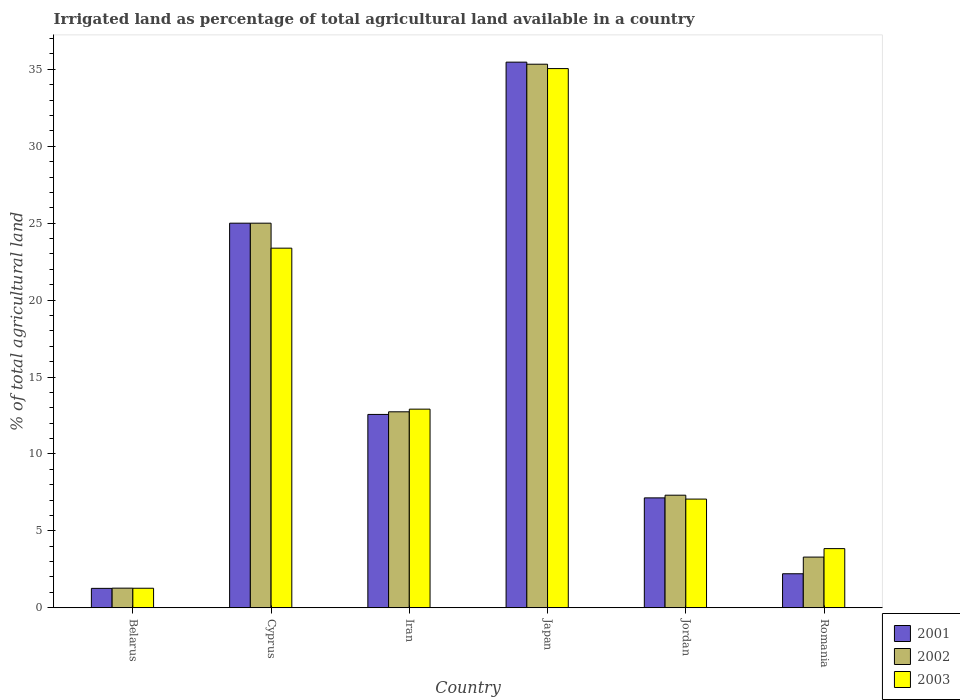Are the number of bars on each tick of the X-axis equal?
Your answer should be compact. Yes. What is the label of the 1st group of bars from the left?
Your response must be concise. Belarus. What is the percentage of irrigated land in 2001 in Iran?
Your response must be concise. 12.57. Across all countries, what is the maximum percentage of irrigated land in 2001?
Offer a very short reply. 35.47. Across all countries, what is the minimum percentage of irrigated land in 2003?
Ensure brevity in your answer.  1.27. In which country was the percentage of irrigated land in 2001 maximum?
Offer a terse response. Japan. In which country was the percentage of irrigated land in 2002 minimum?
Your answer should be compact. Belarus. What is the total percentage of irrigated land in 2002 in the graph?
Offer a very short reply. 84.96. What is the difference between the percentage of irrigated land in 2002 in Belarus and that in Romania?
Your response must be concise. -2.02. What is the difference between the percentage of irrigated land in 2002 in Cyprus and the percentage of irrigated land in 2001 in Iran?
Make the answer very short. 12.43. What is the average percentage of irrigated land in 2001 per country?
Provide a short and direct response. 13.94. What is the difference between the percentage of irrigated land of/in 2001 and percentage of irrigated land of/in 2003 in Belarus?
Offer a very short reply. -0.01. In how many countries, is the percentage of irrigated land in 2001 greater than 8 %?
Give a very brief answer. 3. What is the ratio of the percentage of irrigated land in 2003 in Cyprus to that in Iran?
Keep it short and to the point. 1.81. Is the percentage of irrigated land in 2003 in Iran less than that in Japan?
Keep it short and to the point. Yes. What is the difference between the highest and the second highest percentage of irrigated land in 2001?
Ensure brevity in your answer.  -10.47. What is the difference between the highest and the lowest percentage of irrigated land in 2002?
Offer a terse response. 34.06. What does the 2nd bar from the right in Jordan represents?
Your response must be concise. 2002. Is it the case that in every country, the sum of the percentage of irrigated land in 2001 and percentage of irrigated land in 2003 is greater than the percentage of irrigated land in 2002?
Give a very brief answer. Yes. How many bars are there?
Keep it short and to the point. 18. Are all the bars in the graph horizontal?
Offer a very short reply. No. How many countries are there in the graph?
Your answer should be compact. 6. What is the difference between two consecutive major ticks on the Y-axis?
Keep it short and to the point. 5. Does the graph contain any zero values?
Provide a short and direct response. No. Does the graph contain grids?
Give a very brief answer. No. What is the title of the graph?
Offer a very short reply. Irrigated land as percentage of total agricultural land available in a country. What is the label or title of the Y-axis?
Your answer should be very brief. % of total agricultural land. What is the % of total agricultural land in 2001 in Belarus?
Give a very brief answer. 1.26. What is the % of total agricultural land of 2002 in Belarus?
Give a very brief answer. 1.27. What is the % of total agricultural land in 2003 in Belarus?
Give a very brief answer. 1.27. What is the % of total agricultural land in 2001 in Cyprus?
Provide a succinct answer. 25. What is the % of total agricultural land of 2003 in Cyprus?
Provide a short and direct response. 23.38. What is the % of total agricultural land of 2001 in Iran?
Make the answer very short. 12.57. What is the % of total agricultural land in 2002 in Iran?
Your answer should be very brief. 12.74. What is the % of total agricultural land in 2003 in Iran?
Your response must be concise. 12.91. What is the % of total agricultural land of 2001 in Japan?
Your response must be concise. 35.47. What is the % of total agricultural land of 2002 in Japan?
Keep it short and to the point. 35.33. What is the % of total agricultural land of 2003 in Japan?
Your answer should be very brief. 35.05. What is the % of total agricultural land in 2001 in Jordan?
Make the answer very short. 7.14. What is the % of total agricultural land in 2002 in Jordan?
Give a very brief answer. 7.32. What is the % of total agricultural land in 2003 in Jordan?
Keep it short and to the point. 7.06. What is the % of total agricultural land in 2001 in Romania?
Provide a short and direct response. 2.21. What is the % of total agricultural land of 2002 in Romania?
Offer a terse response. 3.29. What is the % of total agricultural land of 2003 in Romania?
Keep it short and to the point. 3.84. Across all countries, what is the maximum % of total agricultural land in 2001?
Give a very brief answer. 35.47. Across all countries, what is the maximum % of total agricultural land in 2002?
Make the answer very short. 35.33. Across all countries, what is the maximum % of total agricultural land in 2003?
Keep it short and to the point. 35.05. Across all countries, what is the minimum % of total agricultural land of 2001?
Make the answer very short. 1.26. Across all countries, what is the minimum % of total agricultural land in 2002?
Keep it short and to the point. 1.27. Across all countries, what is the minimum % of total agricultural land in 2003?
Offer a terse response. 1.27. What is the total % of total agricultural land of 2001 in the graph?
Provide a succinct answer. 83.65. What is the total % of total agricultural land in 2002 in the graph?
Offer a terse response. 84.96. What is the total % of total agricultural land in 2003 in the graph?
Give a very brief answer. 83.52. What is the difference between the % of total agricultural land of 2001 in Belarus and that in Cyprus?
Offer a very short reply. -23.74. What is the difference between the % of total agricultural land in 2002 in Belarus and that in Cyprus?
Offer a very short reply. -23.73. What is the difference between the % of total agricultural land of 2003 in Belarus and that in Cyprus?
Ensure brevity in your answer.  -22.11. What is the difference between the % of total agricultural land of 2001 in Belarus and that in Iran?
Make the answer very short. -11.31. What is the difference between the % of total agricultural land in 2002 in Belarus and that in Iran?
Make the answer very short. -11.46. What is the difference between the % of total agricultural land in 2003 in Belarus and that in Iran?
Make the answer very short. -11.64. What is the difference between the % of total agricultural land of 2001 in Belarus and that in Japan?
Provide a short and direct response. -34.21. What is the difference between the % of total agricultural land in 2002 in Belarus and that in Japan?
Keep it short and to the point. -34.06. What is the difference between the % of total agricultural land in 2003 in Belarus and that in Japan?
Your response must be concise. -33.78. What is the difference between the % of total agricultural land of 2001 in Belarus and that in Jordan?
Ensure brevity in your answer.  -5.88. What is the difference between the % of total agricultural land in 2002 in Belarus and that in Jordan?
Provide a succinct answer. -6.04. What is the difference between the % of total agricultural land in 2003 in Belarus and that in Jordan?
Give a very brief answer. -5.8. What is the difference between the % of total agricultural land in 2001 in Belarus and that in Romania?
Your answer should be compact. -0.95. What is the difference between the % of total agricultural land of 2002 in Belarus and that in Romania?
Your answer should be compact. -2.02. What is the difference between the % of total agricultural land in 2003 in Belarus and that in Romania?
Your answer should be compact. -2.58. What is the difference between the % of total agricultural land of 2001 in Cyprus and that in Iran?
Your response must be concise. 12.43. What is the difference between the % of total agricultural land in 2002 in Cyprus and that in Iran?
Give a very brief answer. 12.26. What is the difference between the % of total agricultural land in 2003 in Cyprus and that in Iran?
Provide a succinct answer. 10.47. What is the difference between the % of total agricultural land in 2001 in Cyprus and that in Japan?
Provide a succinct answer. -10.47. What is the difference between the % of total agricultural land of 2002 in Cyprus and that in Japan?
Ensure brevity in your answer.  -10.33. What is the difference between the % of total agricultural land in 2003 in Cyprus and that in Japan?
Ensure brevity in your answer.  -11.67. What is the difference between the % of total agricultural land in 2001 in Cyprus and that in Jordan?
Your answer should be very brief. 17.86. What is the difference between the % of total agricultural land of 2002 in Cyprus and that in Jordan?
Your response must be concise. 17.68. What is the difference between the % of total agricultural land in 2003 in Cyprus and that in Jordan?
Offer a very short reply. 16.31. What is the difference between the % of total agricultural land of 2001 in Cyprus and that in Romania?
Offer a terse response. 22.79. What is the difference between the % of total agricultural land of 2002 in Cyprus and that in Romania?
Ensure brevity in your answer.  21.71. What is the difference between the % of total agricultural land in 2003 in Cyprus and that in Romania?
Offer a terse response. 19.53. What is the difference between the % of total agricultural land of 2001 in Iran and that in Japan?
Provide a succinct answer. -22.9. What is the difference between the % of total agricultural land of 2002 in Iran and that in Japan?
Give a very brief answer. -22.6. What is the difference between the % of total agricultural land of 2003 in Iran and that in Japan?
Make the answer very short. -22.14. What is the difference between the % of total agricultural land of 2001 in Iran and that in Jordan?
Provide a short and direct response. 5.42. What is the difference between the % of total agricultural land of 2002 in Iran and that in Jordan?
Keep it short and to the point. 5.42. What is the difference between the % of total agricultural land of 2003 in Iran and that in Jordan?
Your answer should be compact. 5.85. What is the difference between the % of total agricultural land of 2001 in Iran and that in Romania?
Offer a very short reply. 10.36. What is the difference between the % of total agricultural land in 2002 in Iran and that in Romania?
Make the answer very short. 9.44. What is the difference between the % of total agricultural land in 2003 in Iran and that in Romania?
Provide a short and direct response. 9.07. What is the difference between the % of total agricultural land of 2001 in Japan and that in Jordan?
Offer a very short reply. 28.33. What is the difference between the % of total agricultural land in 2002 in Japan and that in Jordan?
Provide a succinct answer. 28.02. What is the difference between the % of total agricultural land in 2003 in Japan and that in Jordan?
Make the answer very short. 27.99. What is the difference between the % of total agricultural land in 2001 in Japan and that in Romania?
Provide a short and direct response. 33.26. What is the difference between the % of total agricultural land of 2002 in Japan and that in Romania?
Make the answer very short. 32.04. What is the difference between the % of total agricultural land in 2003 in Japan and that in Romania?
Offer a terse response. 31.21. What is the difference between the % of total agricultural land in 2001 in Jordan and that in Romania?
Your answer should be very brief. 4.93. What is the difference between the % of total agricultural land of 2002 in Jordan and that in Romania?
Ensure brevity in your answer.  4.02. What is the difference between the % of total agricultural land in 2003 in Jordan and that in Romania?
Keep it short and to the point. 3.22. What is the difference between the % of total agricultural land of 2001 in Belarus and the % of total agricultural land of 2002 in Cyprus?
Your response must be concise. -23.74. What is the difference between the % of total agricultural land of 2001 in Belarus and the % of total agricultural land of 2003 in Cyprus?
Ensure brevity in your answer.  -22.12. What is the difference between the % of total agricultural land of 2002 in Belarus and the % of total agricultural land of 2003 in Cyprus?
Keep it short and to the point. -22.1. What is the difference between the % of total agricultural land of 2001 in Belarus and the % of total agricultural land of 2002 in Iran?
Provide a succinct answer. -11.48. What is the difference between the % of total agricultural land of 2001 in Belarus and the % of total agricultural land of 2003 in Iran?
Offer a very short reply. -11.65. What is the difference between the % of total agricultural land in 2002 in Belarus and the % of total agricultural land in 2003 in Iran?
Offer a terse response. -11.64. What is the difference between the % of total agricultural land in 2001 in Belarus and the % of total agricultural land in 2002 in Japan?
Give a very brief answer. -34.08. What is the difference between the % of total agricultural land of 2001 in Belarus and the % of total agricultural land of 2003 in Japan?
Make the answer very short. -33.79. What is the difference between the % of total agricultural land in 2002 in Belarus and the % of total agricultural land in 2003 in Japan?
Provide a succinct answer. -33.78. What is the difference between the % of total agricultural land of 2001 in Belarus and the % of total agricultural land of 2002 in Jordan?
Offer a terse response. -6.06. What is the difference between the % of total agricultural land in 2001 in Belarus and the % of total agricultural land in 2003 in Jordan?
Keep it short and to the point. -5.8. What is the difference between the % of total agricultural land of 2002 in Belarus and the % of total agricultural land of 2003 in Jordan?
Give a very brief answer. -5.79. What is the difference between the % of total agricultural land in 2001 in Belarus and the % of total agricultural land in 2002 in Romania?
Make the answer very short. -2.03. What is the difference between the % of total agricultural land in 2001 in Belarus and the % of total agricultural land in 2003 in Romania?
Your answer should be compact. -2.58. What is the difference between the % of total agricultural land of 2002 in Belarus and the % of total agricultural land of 2003 in Romania?
Make the answer very short. -2.57. What is the difference between the % of total agricultural land in 2001 in Cyprus and the % of total agricultural land in 2002 in Iran?
Ensure brevity in your answer.  12.26. What is the difference between the % of total agricultural land in 2001 in Cyprus and the % of total agricultural land in 2003 in Iran?
Offer a very short reply. 12.09. What is the difference between the % of total agricultural land in 2002 in Cyprus and the % of total agricultural land in 2003 in Iran?
Make the answer very short. 12.09. What is the difference between the % of total agricultural land in 2001 in Cyprus and the % of total agricultural land in 2002 in Japan?
Ensure brevity in your answer.  -10.33. What is the difference between the % of total agricultural land of 2001 in Cyprus and the % of total agricultural land of 2003 in Japan?
Your answer should be compact. -10.05. What is the difference between the % of total agricultural land of 2002 in Cyprus and the % of total agricultural land of 2003 in Japan?
Keep it short and to the point. -10.05. What is the difference between the % of total agricultural land of 2001 in Cyprus and the % of total agricultural land of 2002 in Jordan?
Give a very brief answer. 17.68. What is the difference between the % of total agricultural land of 2001 in Cyprus and the % of total agricultural land of 2003 in Jordan?
Your answer should be very brief. 17.94. What is the difference between the % of total agricultural land of 2002 in Cyprus and the % of total agricultural land of 2003 in Jordan?
Offer a terse response. 17.94. What is the difference between the % of total agricultural land in 2001 in Cyprus and the % of total agricultural land in 2002 in Romania?
Ensure brevity in your answer.  21.71. What is the difference between the % of total agricultural land of 2001 in Cyprus and the % of total agricultural land of 2003 in Romania?
Keep it short and to the point. 21.16. What is the difference between the % of total agricultural land in 2002 in Cyprus and the % of total agricultural land in 2003 in Romania?
Your answer should be compact. 21.16. What is the difference between the % of total agricultural land in 2001 in Iran and the % of total agricultural land in 2002 in Japan?
Offer a terse response. -22.77. What is the difference between the % of total agricultural land of 2001 in Iran and the % of total agricultural land of 2003 in Japan?
Make the answer very short. -22.48. What is the difference between the % of total agricultural land in 2002 in Iran and the % of total agricultural land in 2003 in Japan?
Provide a short and direct response. -22.31. What is the difference between the % of total agricultural land in 2001 in Iran and the % of total agricultural land in 2002 in Jordan?
Offer a terse response. 5.25. What is the difference between the % of total agricultural land in 2001 in Iran and the % of total agricultural land in 2003 in Jordan?
Provide a short and direct response. 5.5. What is the difference between the % of total agricultural land of 2002 in Iran and the % of total agricultural land of 2003 in Jordan?
Your answer should be very brief. 5.67. What is the difference between the % of total agricultural land of 2001 in Iran and the % of total agricultural land of 2002 in Romania?
Your response must be concise. 9.27. What is the difference between the % of total agricultural land of 2001 in Iran and the % of total agricultural land of 2003 in Romania?
Your response must be concise. 8.72. What is the difference between the % of total agricultural land in 2002 in Iran and the % of total agricultural land in 2003 in Romania?
Offer a terse response. 8.89. What is the difference between the % of total agricultural land of 2001 in Japan and the % of total agricultural land of 2002 in Jordan?
Your answer should be compact. 28.15. What is the difference between the % of total agricultural land in 2001 in Japan and the % of total agricultural land in 2003 in Jordan?
Provide a succinct answer. 28.4. What is the difference between the % of total agricultural land in 2002 in Japan and the % of total agricultural land in 2003 in Jordan?
Offer a terse response. 28.27. What is the difference between the % of total agricultural land in 2001 in Japan and the % of total agricultural land in 2002 in Romania?
Your answer should be very brief. 32.18. What is the difference between the % of total agricultural land of 2001 in Japan and the % of total agricultural land of 2003 in Romania?
Provide a succinct answer. 31.62. What is the difference between the % of total agricultural land of 2002 in Japan and the % of total agricultural land of 2003 in Romania?
Your answer should be compact. 31.49. What is the difference between the % of total agricultural land of 2001 in Jordan and the % of total agricultural land of 2002 in Romania?
Ensure brevity in your answer.  3.85. What is the difference between the % of total agricultural land of 2001 in Jordan and the % of total agricultural land of 2003 in Romania?
Your answer should be compact. 3.3. What is the difference between the % of total agricultural land in 2002 in Jordan and the % of total agricultural land in 2003 in Romania?
Provide a succinct answer. 3.47. What is the average % of total agricultural land in 2001 per country?
Offer a terse response. 13.94. What is the average % of total agricultural land of 2002 per country?
Your answer should be very brief. 14.16. What is the average % of total agricultural land in 2003 per country?
Make the answer very short. 13.92. What is the difference between the % of total agricultural land in 2001 and % of total agricultural land in 2002 in Belarus?
Keep it short and to the point. -0.01. What is the difference between the % of total agricultural land in 2001 and % of total agricultural land in 2003 in Belarus?
Keep it short and to the point. -0.01. What is the difference between the % of total agricultural land in 2002 and % of total agricultural land in 2003 in Belarus?
Offer a terse response. 0.01. What is the difference between the % of total agricultural land of 2001 and % of total agricultural land of 2002 in Cyprus?
Ensure brevity in your answer.  0. What is the difference between the % of total agricultural land of 2001 and % of total agricultural land of 2003 in Cyprus?
Provide a short and direct response. 1.62. What is the difference between the % of total agricultural land in 2002 and % of total agricultural land in 2003 in Cyprus?
Ensure brevity in your answer.  1.62. What is the difference between the % of total agricultural land of 2001 and % of total agricultural land of 2002 in Iran?
Offer a very short reply. -0.17. What is the difference between the % of total agricultural land in 2001 and % of total agricultural land in 2003 in Iran?
Ensure brevity in your answer.  -0.34. What is the difference between the % of total agricultural land of 2002 and % of total agricultural land of 2003 in Iran?
Give a very brief answer. -0.17. What is the difference between the % of total agricultural land of 2001 and % of total agricultural land of 2002 in Japan?
Offer a terse response. 0.13. What is the difference between the % of total agricultural land of 2001 and % of total agricultural land of 2003 in Japan?
Your response must be concise. 0.42. What is the difference between the % of total agricultural land in 2002 and % of total agricultural land in 2003 in Japan?
Offer a terse response. 0.28. What is the difference between the % of total agricultural land in 2001 and % of total agricultural land in 2002 in Jordan?
Your response must be concise. -0.17. What is the difference between the % of total agricultural land of 2001 and % of total agricultural land of 2003 in Jordan?
Your answer should be compact. 0.08. What is the difference between the % of total agricultural land in 2002 and % of total agricultural land in 2003 in Jordan?
Provide a succinct answer. 0.25. What is the difference between the % of total agricultural land of 2001 and % of total agricultural land of 2002 in Romania?
Give a very brief answer. -1.08. What is the difference between the % of total agricultural land of 2001 and % of total agricultural land of 2003 in Romania?
Keep it short and to the point. -1.63. What is the difference between the % of total agricultural land in 2002 and % of total agricultural land in 2003 in Romania?
Provide a short and direct response. -0.55. What is the ratio of the % of total agricultural land of 2001 in Belarus to that in Cyprus?
Make the answer very short. 0.05. What is the ratio of the % of total agricultural land in 2002 in Belarus to that in Cyprus?
Your response must be concise. 0.05. What is the ratio of the % of total agricultural land in 2003 in Belarus to that in Cyprus?
Provide a succinct answer. 0.05. What is the ratio of the % of total agricultural land in 2001 in Belarus to that in Iran?
Provide a succinct answer. 0.1. What is the ratio of the % of total agricultural land of 2002 in Belarus to that in Iran?
Keep it short and to the point. 0.1. What is the ratio of the % of total agricultural land of 2003 in Belarus to that in Iran?
Your answer should be compact. 0.1. What is the ratio of the % of total agricultural land in 2001 in Belarus to that in Japan?
Provide a succinct answer. 0.04. What is the ratio of the % of total agricultural land in 2002 in Belarus to that in Japan?
Offer a very short reply. 0.04. What is the ratio of the % of total agricultural land of 2003 in Belarus to that in Japan?
Give a very brief answer. 0.04. What is the ratio of the % of total agricultural land in 2001 in Belarus to that in Jordan?
Offer a terse response. 0.18. What is the ratio of the % of total agricultural land in 2002 in Belarus to that in Jordan?
Offer a terse response. 0.17. What is the ratio of the % of total agricultural land of 2003 in Belarus to that in Jordan?
Ensure brevity in your answer.  0.18. What is the ratio of the % of total agricultural land of 2001 in Belarus to that in Romania?
Provide a short and direct response. 0.57. What is the ratio of the % of total agricultural land of 2002 in Belarus to that in Romania?
Offer a terse response. 0.39. What is the ratio of the % of total agricultural land in 2003 in Belarus to that in Romania?
Make the answer very short. 0.33. What is the ratio of the % of total agricultural land in 2001 in Cyprus to that in Iran?
Provide a succinct answer. 1.99. What is the ratio of the % of total agricultural land of 2002 in Cyprus to that in Iran?
Your response must be concise. 1.96. What is the ratio of the % of total agricultural land in 2003 in Cyprus to that in Iran?
Offer a terse response. 1.81. What is the ratio of the % of total agricultural land in 2001 in Cyprus to that in Japan?
Ensure brevity in your answer.  0.7. What is the ratio of the % of total agricultural land in 2002 in Cyprus to that in Japan?
Make the answer very short. 0.71. What is the ratio of the % of total agricultural land of 2003 in Cyprus to that in Japan?
Your answer should be compact. 0.67. What is the ratio of the % of total agricultural land of 2001 in Cyprus to that in Jordan?
Offer a terse response. 3.5. What is the ratio of the % of total agricultural land of 2002 in Cyprus to that in Jordan?
Ensure brevity in your answer.  3.42. What is the ratio of the % of total agricultural land of 2003 in Cyprus to that in Jordan?
Offer a very short reply. 3.31. What is the ratio of the % of total agricultural land in 2001 in Cyprus to that in Romania?
Your response must be concise. 11.31. What is the ratio of the % of total agricultural land in 2002 in Cyprus to that in Romania?
Offer a very short reply. 7.59. What is the ratio of the % of total agricultural land of 2003 in Cyprus to that in Romania?
Your answer should be very brief. 6.08. What is the ratio of the % of total agricultural land in 2001 in Iran to that in Japan?
Your answer should be compact. 0.35. What is the ratio of the % of total agricultural land in 2002 in Iran to that in Japan?
Ensure brevity in your answer.  0.36. What is the ratio of the % of total agricultural land of 2003 in Iran to that in Japan?
Ensure brevity in your answer.  0.37. What is the ratio of the % of total agricultural land in 2001 in Iran to that in Jordan?
Offer a terse response. 1.76. What is the ratio of the % of total agricultural land of 2002 in Iran to that in Jordan?
Ensure brevity in your answer.  1.74. What is the ratio of the % of total agricultural land in 2003 in Iran to that in Jordan?
Give a very brief answer. 1.83. What is the ratio of the % of total agricultural land of 2001 in Iran to that in Romania?
Offer a very short reply. 5.69. What is the ratio of the % of total agricultural land of 2002 in Iran to that in Romania?
Keep it short and to the point. 3.87. What is the ratio of the % of total agricultural land in 2003 in Iran to that in Romania?
Ensure brevity in your answer.  3.36. What is the ratio of the % of total agricultural land in 2001 in Japan to that in Jordan?
Your answer should be compact. 4.97. What is the ratio of the % of total agricultural land in 2002 in Japan to that in Jordan?
Give a very brief answer. 4.83. What is the ratio of the % of total agricultural land in 2003 in Japan to that in Jordan?
Make the answer very short. 4.96. What is the ratio of the % of total agricultural land in 2001 in Japan to that in Romania?
Keep it short and to the point. 16.05. What is the ratio of the % of total agricultural land of 2002 in Japan to that in Romania?
Offer a terse response. 10.73. What is the ratio of the % of total agricultural land in 2003 in Japan to that in Romania?
Provide a short and direct response. 9.12. What is the ratio of the % of total agricultural land of 2001 in Jordan to that in Romania?
Provide a short and direct response. 3.23. What is the ratio of the % of total agricultural land of 2002 in Jordan to that in Romania?
Provide a succinct answer. 2.22. What is the ratio of the % of total agricultural land of 2003 in Jordan to that in Romania?
Offer a very short reply. 1.84. What is the difference between the highest and the second highest % of total agricultural land in 2001?
Provide a short and direct response. 10.47. What is the difference between the highest and the second highest % of total agricultural land in 2002?
Your answer should be compact. 10.33. What is the difference between the highest and the second highest % of total agricultural land of 2003?
Provide a succinct answer. 11.67. What is the difference between the highest and the lowest % of total agricultural land in 2001?
Offer a very short reply. 34.21. What is the difference between the highest and the lowest % of total agricultural land in 2002?
Make the answer very short. 34.06. What is the difference between the highest and the lowest % of total agricultural land in 2003?
Your answer should be very brief. 33.78. 